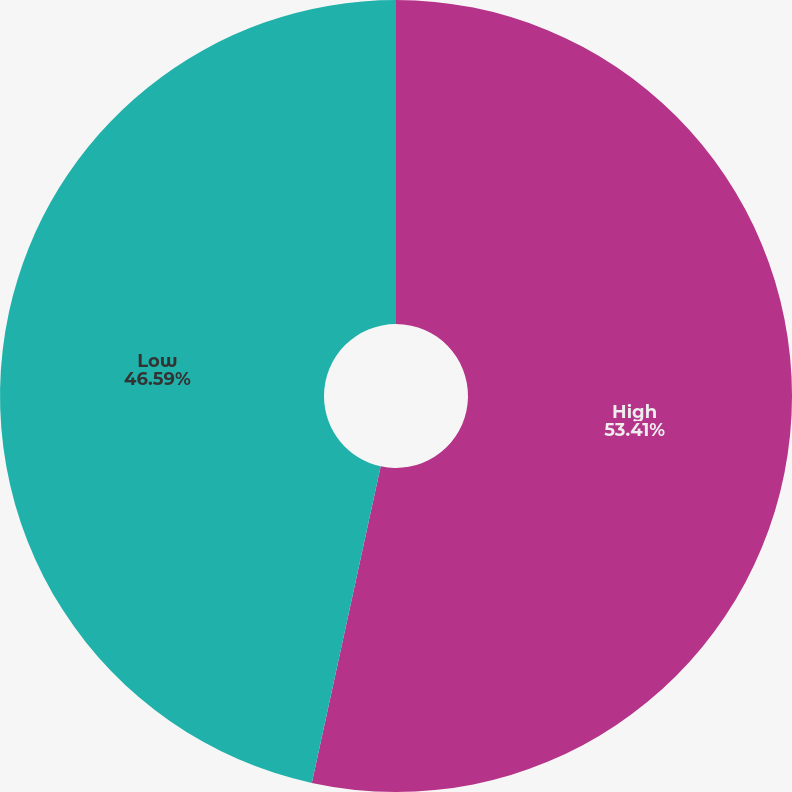<chart> <loc_0><loc_0><loc_500><loc_500><pie_chart><fcel>High<fcel>Low<nl><fcel>53.41%<fcel>46.59%<nl></chart> 